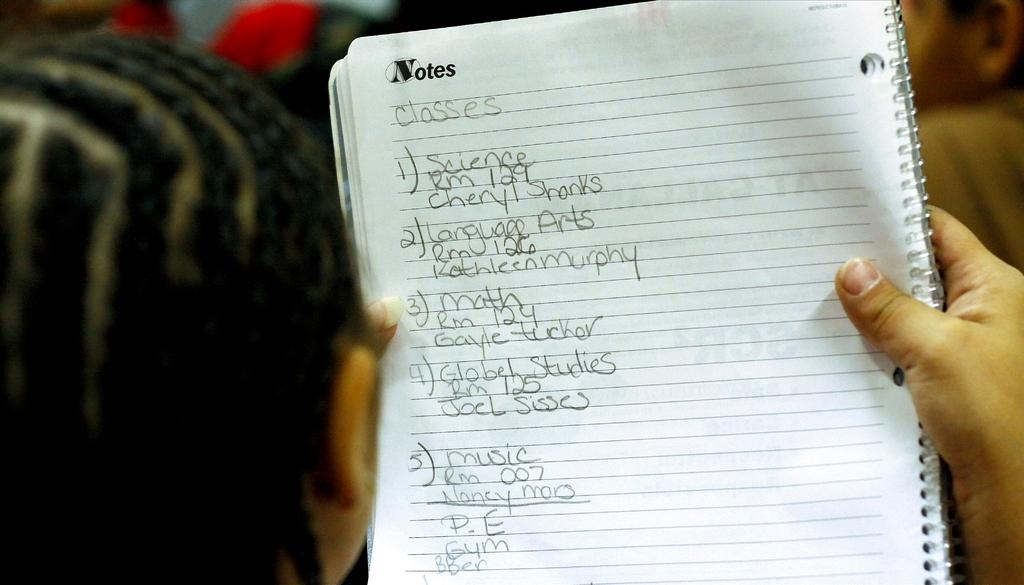<image>
Provide a brief description of the given image. A notebook containing a list of classes and names of people 